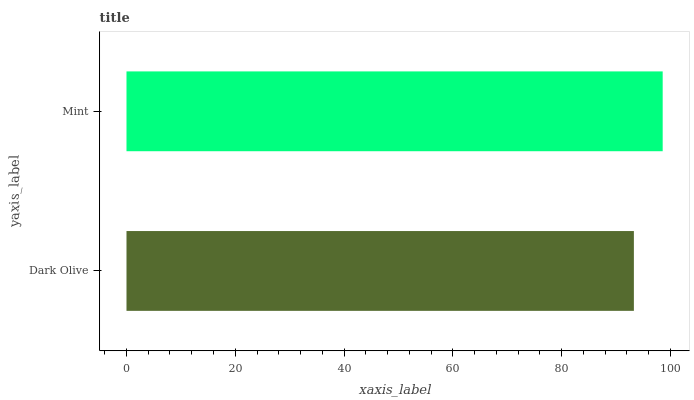Is Dark Olive the minimum?
Answer yes or no. Yes. Is Mint the maximum?
Answer yes or no. Yes. Is Mint the minimum?
Answer yes or no. No. Is Mint greater than Dark Olive?
Answer yes or no. Yes. Is Dark Olive less than Mint?
Answer yes or no. Yes. Is Dark Olive greater than Mint?
Answer yes or no. No. Is Mint less than Dark Olive?
Answer yes or no. No. Is Mint the high median?
Answer yes or no. Yes. Is Dark Olive the low median?
Answer yes or no. Yes. Is Dark Olive the high median?
Answer yes or no. No. Is Mint the low median?
Answer yes or no. No. 